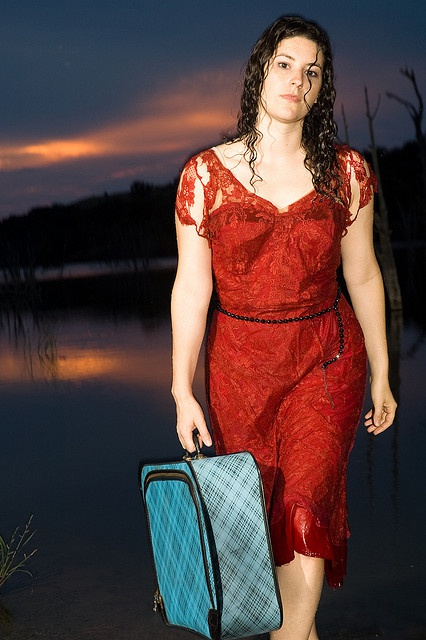Describe the objects in this image and their specific colors. I can see people in darkblue, brown, maroon, black, and ivory tones and suitcase in darkblue, teal, black, and lightblue tones in this image. 